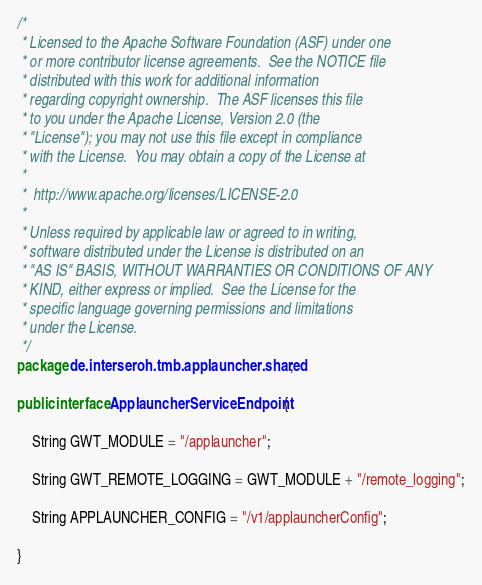Convert code to text. <code><loc_0><loc_0><loc_500><loc_500><_Java_>/*
 * Licensed to the Apache Software Foundation (ASF) under one
 * or more contributor license agreements.  See the NOTICE file
 * distributed with this work for additional information
 * regarding copyright ownership.  The ASF licenses this file
 * to you under the Apache License, Version 2.0 (the
 * "License"); you may not use this file except in compliance
 * with the License.  You may obtain a copy of the License at
 *
 *  http://www.apache.org/licenses/LICENSE-2.0
 *
 * Unless required by applicable law or agreed to in writing,
 * software distributed under the License is distributed on an
 * "AS IS" BASIS, WITHOUT WARRANTIES OR CONDITIONS OF ANY
 * KIND, either express or implied.  See the License for the
 * specific language governing permissions and limitations
 * under the License.
 */
package de.interseroh.tmb.applauncher.shared;

public interface ApplauncherServiceEndpoint {

	String GWT_MODULE = "/applauncher";

	String GWT_REMOTE_LOGGING = GWT_MODULE + "/remote_logging";

	String APPLAUNCHER_CONFIG = "/v1/applauncherConfig";

}
</code> 